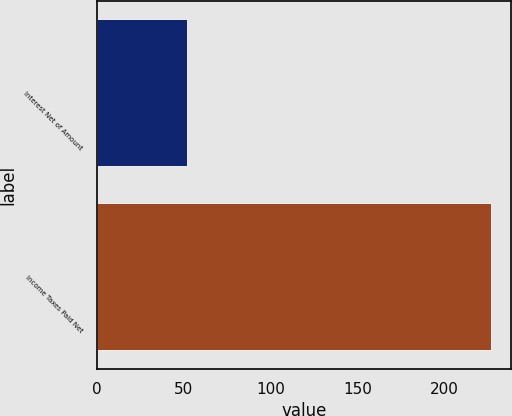Convert chart to OTSL. <chart><loc_0><loc_0><loc_500><loc_500><bar_chart><fcel>Interest Net of Amount<fcel>Income Taxes Paid Net<nl><fcel>52<fcel>227<nl></chart> 